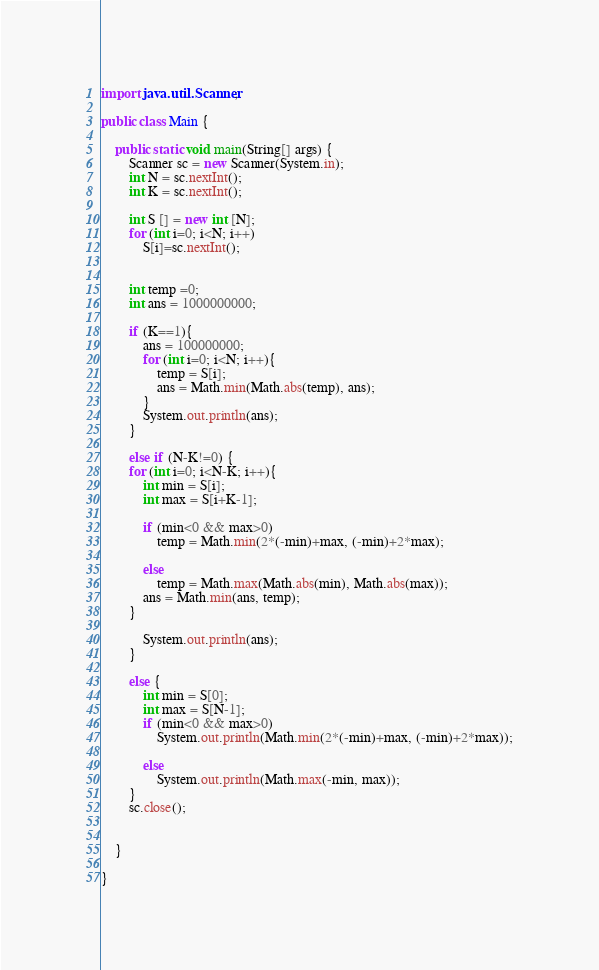Convert code to text. <code><loc_0><loc_0><loc_500><loc_500><_Java_>import java.util.Scanner;

public class Main {

	public static void main(String[] args) {
		Scanner sc = new Scanner(System.in);
		int N = sc.nextInt();
		int K = sc.nextInt();
		
		int S [] = new int [N];
		for (int i=0; i<N; i++)
			S[i]=sc.nextInt();
		
		
		int temp =0;
		int ans = 1000000000;
		
		if (K==1){
			ans = 100000000;
			for (int i=0; i<N; i++){
				temp = S[i];
				ans = Math.min(Math.abs(temp), ans);
			}
			System.out.println(ans);
		}
		
		else if (N-K!=0) {
		for (int i=0; i<N-K; i++){
			int min = S[i];
			int max = S[i+K-1];
			
			if (min<0 && max>0)
				temp = Math.min(2*(-min)+max, (-min)+2*max);
			
			else
				temp = Math.max(Math.abs(min), Math.abs(max));
			ans = Math.min(ans, temp);
		}
		
			System.out.println(ans);
		}
		
		else {
			int min = S[0];
			int max = S[N-1];
			if (min<0 && max>0)
				System.out.println(Math.min(2*(-min)+max, (-min)+2*max));
			
			else
				System.out.println(Math.max(-min, max));
		}
		sc.close();
		
		
	}

}
</code> 